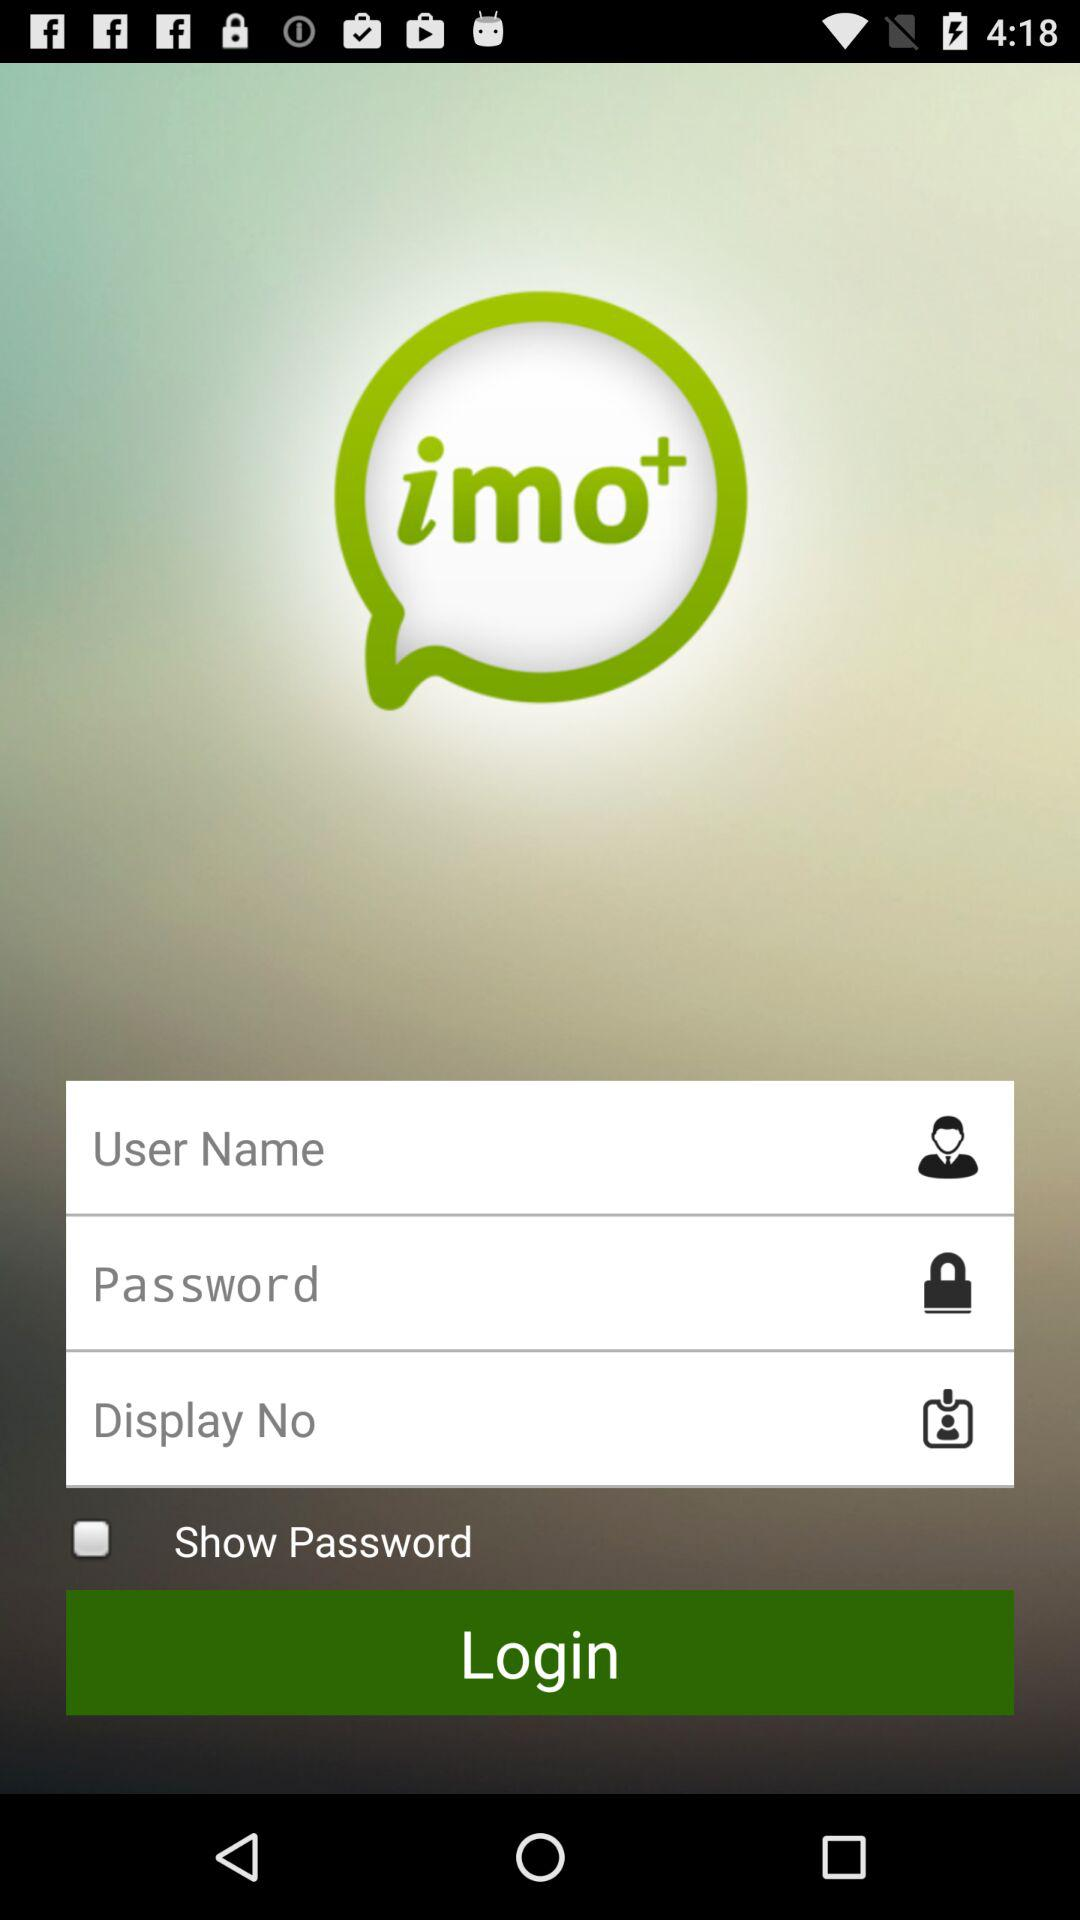What's the status of the "show password"? The status is "off". 